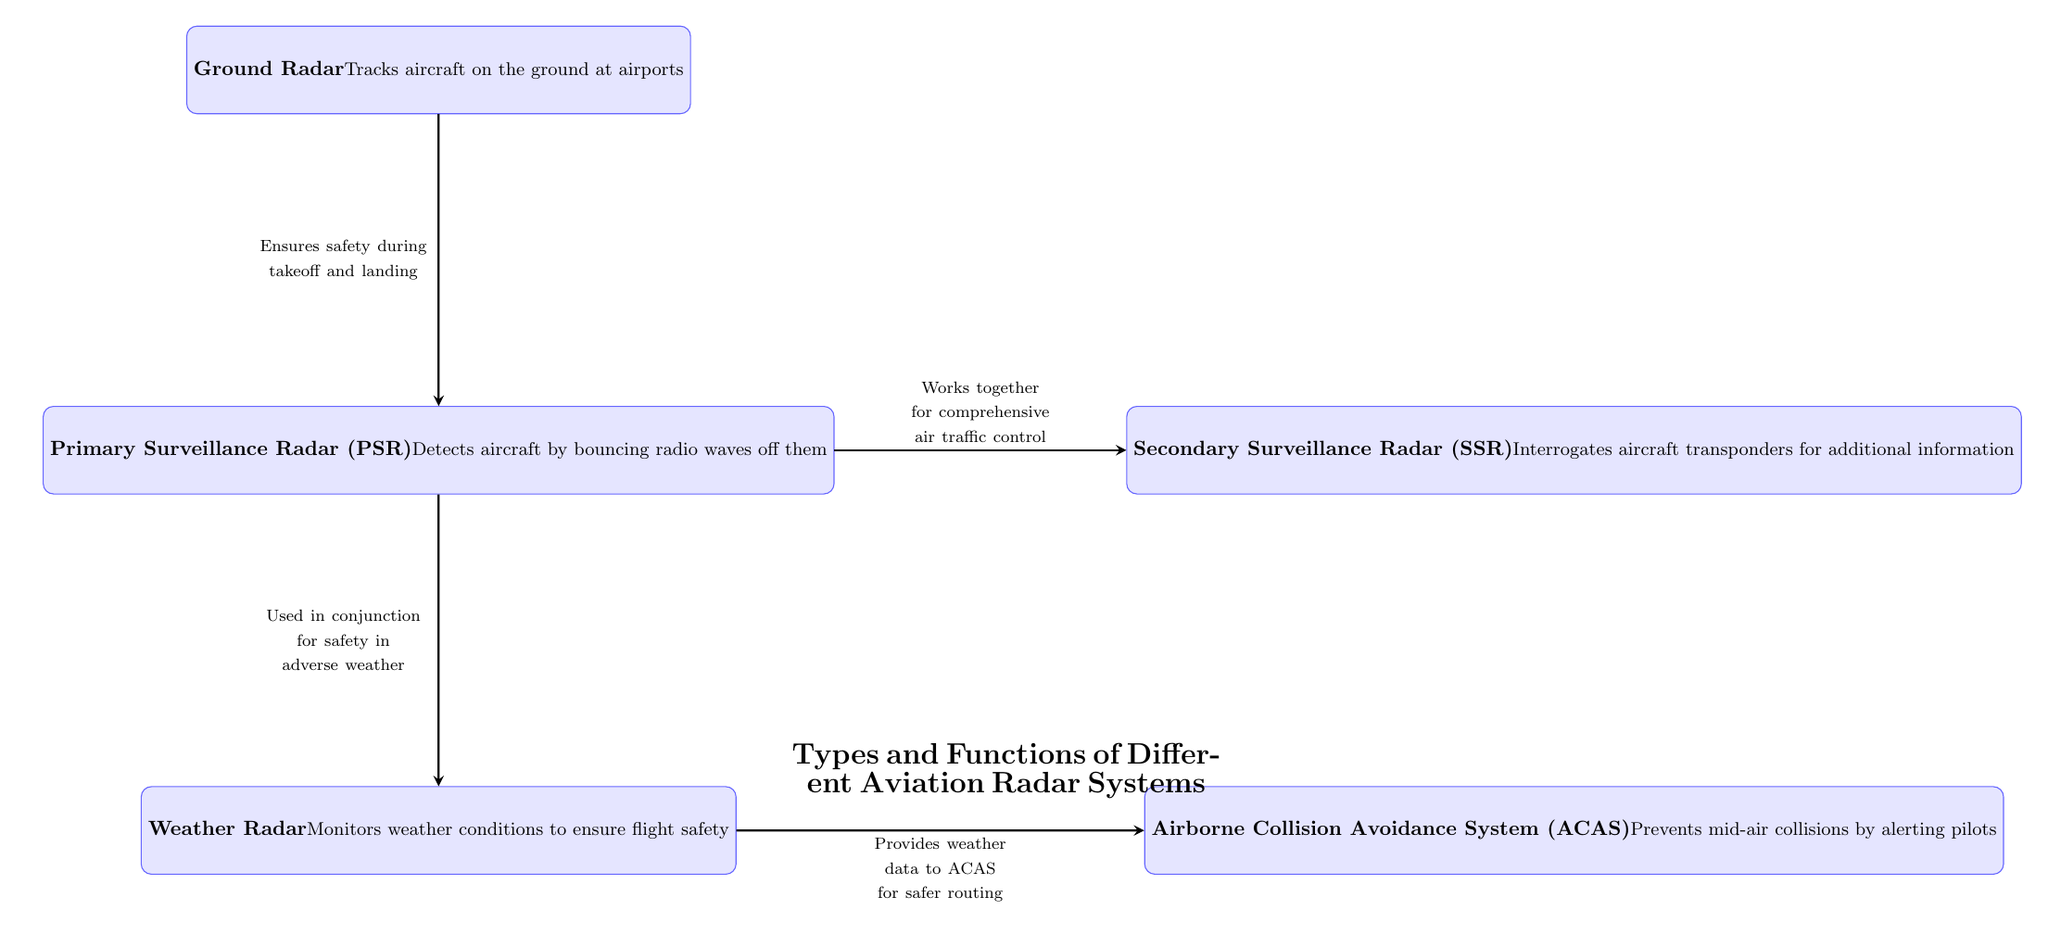What is the function of Primary Surveillance Radar (PSR)? The diagram indicates that PSR detects aircraft by bouncing radio waves off them, which is stated within its description.
Answer: Detects aircraft by bouncing radio waves off them How many types of radar systems are shown in the diagram? The diagram lists five radar systems: PSR, SSR, Weather Radar, ACAS, and Ground Radar, making a total of five distinct systems.
Answer: Five What does Weather Radar monitor? According to the description in the diagram, Weather Radar monitors weather conditions to ensure flight safety.
Answer: Monitors weather conditions to ensure flight safety Which radar system provides weather data to ACAS? The diagram shows an arrow from Weather Radar to ACAS, with a label stating that it provides weather data, establishing a link between these two systems in that context.
Answer: Weather Radar Identify the radar system that tracks aircraft on the ground at airports. The description under the Ground Radar states that it tracks aircraft on the ground at airports, providing clear identification of its function.
Answer: Ground Radar Which two radar systems work together for comprehensive air traffic control? The diagram indicates a connection between PSR and SSR, with the label explicitly mentioning their collaborative function for air traffic control, affirming their interconnected roles.
Answer: PSR and SSR What is the relationship between Ground Radar and PSR? There is an arrow connecting Ground Radar to PSR labeled as ensuring safety during takeoff and landing, which implies that Ground Radar provides relevant data to PSR for safety measures.
Answer: Ensures safety during takeoff and landing How does Weather Radar contribute to ACAS functionality? The diagram shows an arrow from Weather Radar to ACAS, labeled with an explanation that Weather Radar provides weather data to ACAS, clarifying that it helps ACAS with safer routing by sharing information about weather conditions.
Answer: Provides weather data to ACAS for safer routing What element connects the PSR and Weather Radar systems? The diagram depicts an arrow from PSR to Weather Radar, with a label that indicates they are used in conjunction for safety in adverse weather, illustrating their interdependence for enhanced safety measures.
Answer: Used in conjunction for safety in adverse weather 